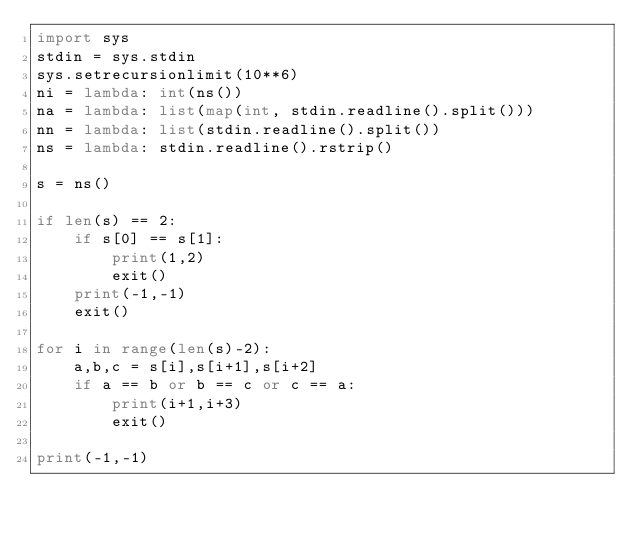<code> <loc_0><loc_0><loc_500><loc_500><_Python_>import sys
stdin = sys.stdin
sys.setrecursionlimit(10**6)
ni = lambda: int(ns())
na = lambda: list(map(int, stdin.readline().split()))
nn = lambda: list(stdin.readline().split())
ns = lambda: stdin.readline().rstrip()

s = ns()

if len(s) == 2:
    if s[0] == s[1]:
        print(1,2)
        exit()
    print(-1,-1)
    exit()

for i in range(len(s)-2):
    a,b,c = s[i],s[i+1],s[i+2]
    if a == b or b == c or c == a:
        print(i+1,i+3)
        exit()

print(-1,-1)</code> 